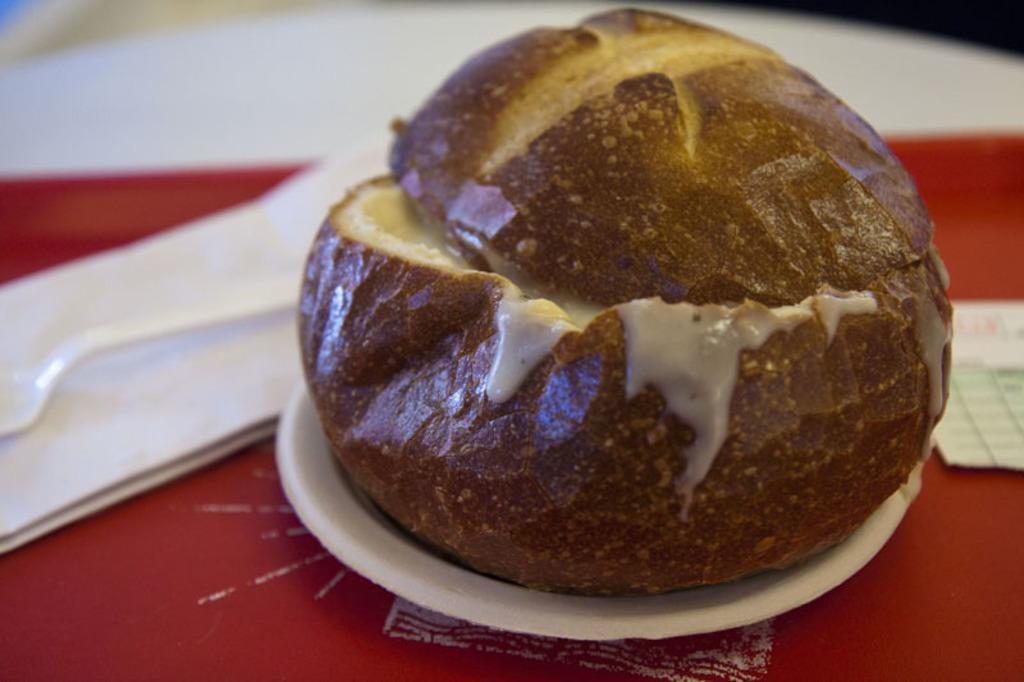Describe this image in one or two sentences. In this image I can see it's a food item on a white color plate. On the left side there is a spoon in white color. 